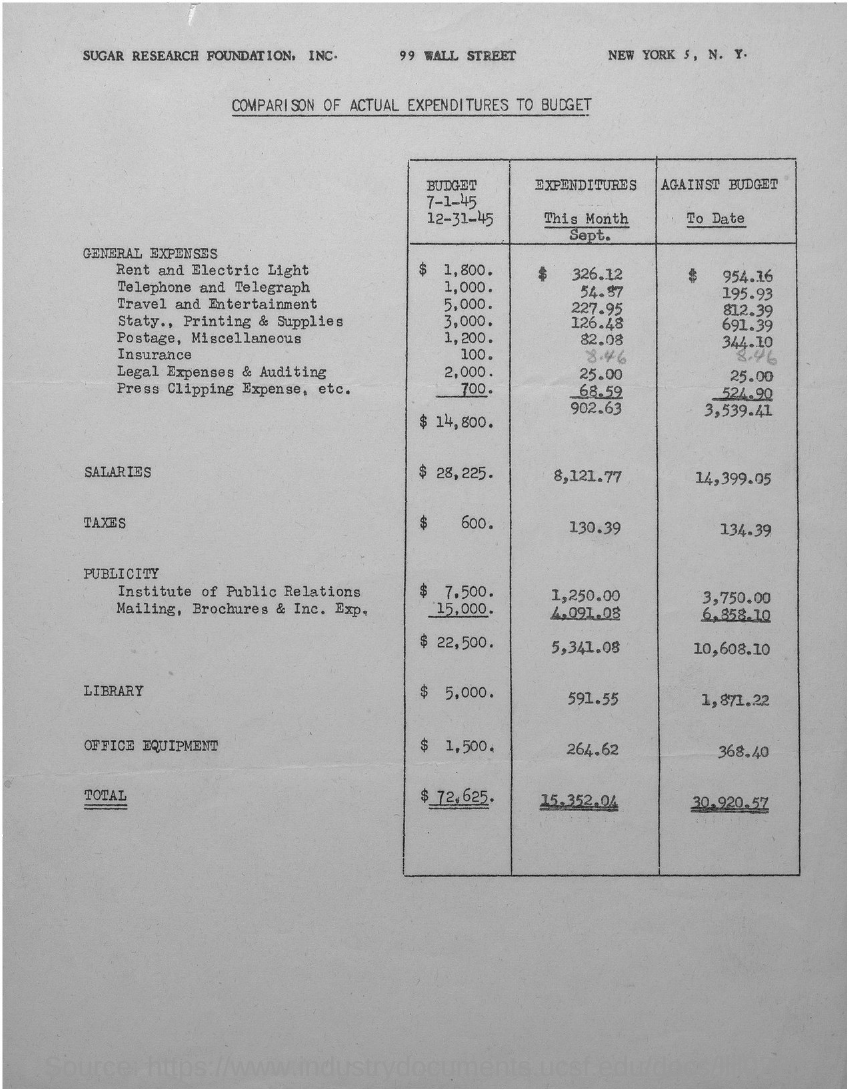Outline some significant characteristics in this image. As of the current date, the amount of salaries against the budget is 14,399.05. The total taxes against the budget to date are 134.39. The total expenditure for the month of September was 15,352.04. The total general expenses against the budget to date are 3,539.41. The salary expenditure for the month of September was 8,121.77... 